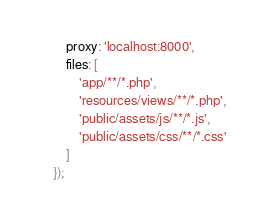Convert code to text. <code><loc_0><loc_0><loc_500><loc_500><_JavaScript_>        proxy: 'localhost:8000',
        files: [
            'app/**/*.php',
            'resources/views/**/*.php',
            'public/assets/js/**/*.js',
            'public/assets/css/**/*.css'
        ]
    });

</code> 